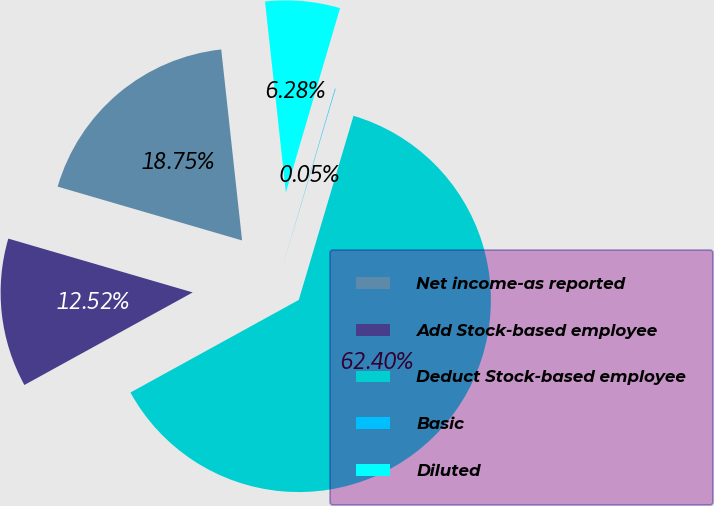Convert chart to OTSL. <chart><loc_0><loc_0><loc_500><loc_500><pie_chart><fcel>Net income-as reported<fcel>Add Stock-based employee<fcel>Deduct Stock-based employee<fcel>Basic<fcel>Diluted<nl><fcel>18.75%<fcel>12.52%<fcel>62.4%<fcel>0.05%<fcel>6.28%<nl></chart> 